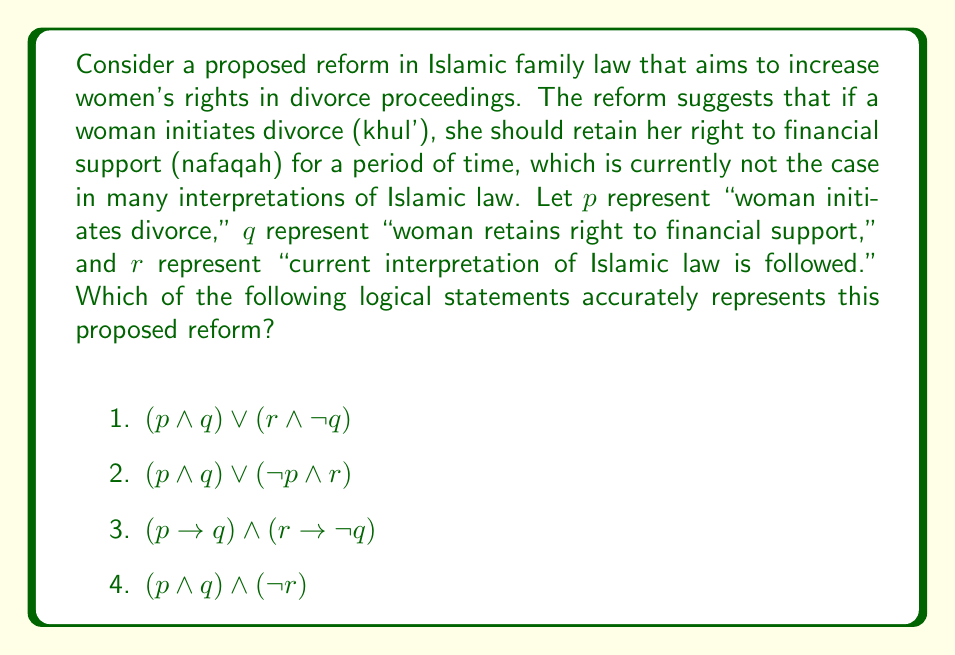Provide a solution to this math problem. To evaluate the logical consistency of the proposed reform, we need to break down the statement and analyze each option:

1) $(p \land q) \lor (r \land \neg q)$
   This statement says: (woman initiates divorce AND retains financial support) OR (current law is followed AND woman does not retain financial support). This doesn't accurately represent the reform because it doesn't link the initiation of divorce to the retention of financial support.

2) $(p \land q) \lor (\neg p \land r)$
   This statement says: (woman initiates divorce AND retains financial support) OR (woman does not initiate divorce AND current law is followed). This is closer but still doesn't capture the full meaning of the reform.

3) $(p \rightarrow q) \land (r \rightarrow \neg q)$
   This statement says: (IF woman initiates divorce THEN she retains financial support) AND (IF current law is followed THEN woman does not retain financial support). This accurately represents the proposed reform because it shows that:
   a) Under the new reform, initiating divorce implies retaining financial support.
   b) Under the current law, a woman does not retain financial support in case of khul'.

4) $(p \land q) \land (\neg r)$
   This statement says: (woman initiates divorce AND retains financial support) AND (current law is not followed). While this captures the essence of the reform, it's too restrictive as it doesn't allow for cases where the current law might still be applicable (e.g., in cases not involving khul').

Therefore, option 3 most accurately represents the logical structure of the proposed reform.
Answer: 3) $(p \rightarrow q) \land (r \rightarrow \neg q)$ 